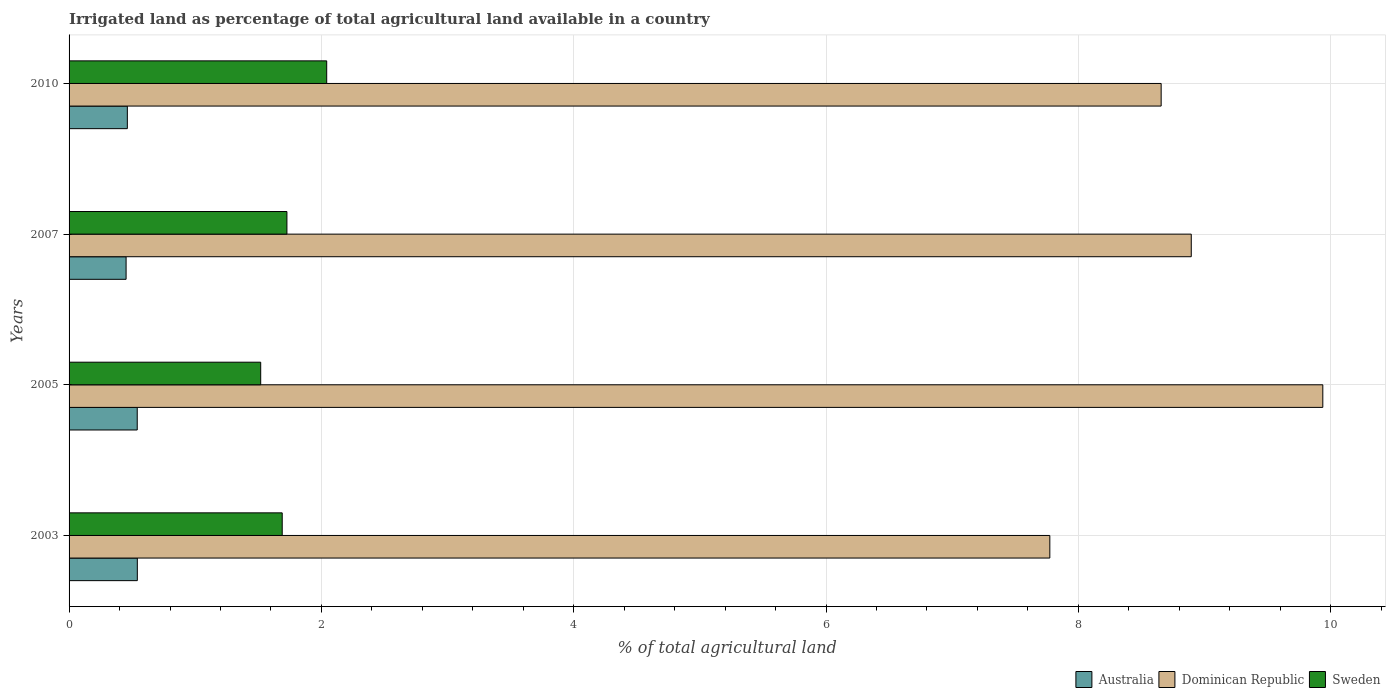Are the number of bars per tick equal to the number of legend labels?
Your answer should be very brief. Yes. Are the number of bars on each tick of the Y-axis equal?
Keep it short and to the point. Yes. In how many cases, is the number of bars for a given year not equal to the number of legend labels?
Offer a very short reply. 0. What is the percentage of irrigated land in Sweden in 2005?
Provide a short and direct response. 1.52. Across all years, what is the maximum percentage of irrigated land in Sweden?
Make the answer very short. 2.04. Across all years, what is the minimum percentage of irrigated land in Sweden?
Your answer should be very brief. 1.52. In which year was the percentage of irrigated land in Australia maximum?
Give a very brief answer. 2003. What is the total percentage of irrigated land in Dominican Republic in the graph?
Your response must be concise. 35.26. What is the difference between the percentage of irrigated land in Australia in 2005 and that in 2007?
Provide a succinct answer. 0.09. What is the difference between the percentage of irrigated land in Australia in 2010 and the percentage of irrigated land in Sweden in 2003?
Provide a short and direct response. -1.23. What is the average percentage of irrigated land in Sweden per year?
Your answer should be very brief. 1.74. In the year 2007, what is the difference between the percentage of irrigated land in Australia and percentage of irrigated land in Sweden?
Offer a very short reply. -1.27. In how many years, is the percentage of irrigated land in Sweden greater than 6.4 %?
Provide a succinct answer. 0. What is the ratio of the percentage of irrigated land in Australia in 2003 to that in 2005?
Provide a succinct answer. 1. Is the difference between the percentage of irrigated land in Australia in 2003 and 2007 greater than the difference between the percentage of irrigated land in Sweden in 2003 and 2007?
Ensure brevity in your answer.  Yes. What is the difference between the highest and the second highest percentage of irrigated land in Sweden?
Your answer should be compact. 0.32. What is the difference between the highest and the lowest percentage of irrigated land in Dominican Republic?
Make the answer very short. 2.16. What does the 2nd bar from the top in 2003 represents?
Keep it short and to the point. Dominican Republic. What does the 3rd bar from the bottom in 2010 represents?
Provide a short and direct response. Sweden. Is it the case that in every year, the sum of the percentage of irrigated land in Sweden and percentage of irrigated land in Australia is greater than the percentage of irrigated land in Dominican Republic?
Keep it short and to the point. No. How many bars are there?
Make the answer very short. 12. Are all the bars in the graph horizontal?
Offer a terse response. Yes. What is the difference between two consecutive major ticks on the X-axis?
Give a very brief answer. 2. Does the graph contain grids?
Ensure brevity in your answer.  Yes. How many legend labels are there?
Provide a succinct answer. 3. What is the title of the graph?
Provide a succinct answer. Irrigated land as percentage of total agricultural land available in a country. Does "Burkina Faso" appear as one of the legend labels in the graph?
Your answer should be very brief. No. What is the label or title of the X-axis?
Offer a very short reply. % of total agricultural land. What is the % of total agricultural land of Australia in 2003?
Offer a terse response. 0.54. What is the % of total agricultural land in Dominican Republic in 2003?
Keep it short and to the point. 7.77. What is the % of total agricultural land of Sweden in 2003?
Your response must be concise. 1.69. What is the % of total agricultural land in Australia in 2005?
Your answer should be very brief. 0.54. What is the % of total agricultural land in Dominican Republic in 2005?
Your response must be concise. 9.94. What is the % of total agricultural land in Sweden in 2005?
Give a very brief answer. 1.52. What is the % of total agricultural land in Australia in 2007?
Provide a succinct answer. 0.45. What is the % of total agricultural land in Dominican Republic in 2007?
Your answer should be compact. 8.9. What is the % of total agricultural land in Sweden in 2007?
Your response must be concise. 1.73. What is the % of total agricultural land of Australia in 2010?
Offer a terse response. 0.46. What is the % of total agricultural land of Dominican Republic in 2010?
Your response must be concise. 8.66. What is the % of total agricultural land of Sweden in 2010?
Your answer should be very brief. 2.04. Across all years, what is the maximum % of total agricultural land of Australia?
Make the answer very short. 0.54. Across all years, what is the maximum % of total agricultural land of Dominican Republic?
Offer a very short reply. 9.94. Across all years, what is the maximum % of total agricultural land in Sweden?
Ensure brevity in your answer.  2.04. Across all years, what is the minimum % of total agricultural land in Australia?
Give a very brief answer. 0.45. Across all years, what is the minimum % of total agricultural land in Dominican Republic?
Provide a short and direct response. 7.77. Across all years, what is the minimum % of total agricultural land of Sweden?
Provide a short and direct response. 1.52. What is the total % of total agricultural land in Australia in the graph?
Your answer should be compact. 2. What is the total % of total agricultural land in Dominican Republic in the graph?
Your answer should be very brief. 35.26. What is the total % of total agricultural land in Sweden in the graph?
Give a very brief answer. 6.98. What is the difference between the % of total agricultural land of Australia in 2003 and that in 2005?
Ensure brevity in your answer.  0. What is the difference between the % of total agricultural land in Dominican Republic in 2003 and that in 2005?
Your answer should be compact. -2.16. What is the difference between the % of total agricultural land in Sweden in 2003 and that in 2005?
Provide a short and direct response. 0.17. What is the difference between the % of total agricultural land in Australia in 2003 and that in 2007?
Your answer should be compact. 0.09. What is the difference between the % of total agricultural land of Dominican Republic in 2003 and that in 2007?
Your response must be concise. -1.12. What is the difference between the % of total agricultural land of Sweden in 2003 and that in 2007?
Ensure brevity in your answer.  -0.04. What is the difference between the % of total agricultural land in Australia in 2003 and that in 2010?
Offer a terse response. 0.08. What is the difference between the % of total agricultural land of Dominican Republic in 2003 and that in 2010?
Your answer should be very brief. -0.88. What is the difference between the % of total agricultural land of Sweden in 2003 and that in 2010?
Offer a very short reply. -0.35. What is the difference between the % of total agricultural land in Australia in 2005 and that in 2007?
Your answer should be compact. 0.09. What is the difference between the % of total agricultural land in Dominican Republic in 2005 and that in 2007?
Offer a very short reply. 1.04. What is the difference between the % of total agricultural land of Sweden in 2005 and that in 2007?
Keep it short and to the point. -0.21. What is the difference between the % of total agricultural land in Australia in 2005 and that in 2010?
Give a very brief answer. 0.08. What is the difference between the % of total agricultural land in Dominican Republic in 2005 and that in 2010?
Your answer should be compact. 1.28. What is the difference between the % of total agricultural land of Sweden in 2005 and that in 2010?
Offer a terse response. -0.52. What is the difference between the % of total agricultural land of Australia in 2007 and that in 2010?
Your answer should be compact. -0.01. What is the difference between the % of total agricultural land of Dominican Republic in 2007 and that in 2010?
Give a very brief answer. 0.24. What is the difference between the % of total agricultural land of Sweden in 2007 and that in 2010?
Provide a succinct answer. -0.32. What is the difference between the % of total agricultural land in Australia in 2003 and the % of total agricultural land in Dominican Republic in 2005?
Offer a very short reply. -9.4. What is the difference between the % of total agricultural land of Australia in 2003 and the % of total agricultural land of Sweden in 2005?
Offer a very short reply. -0.98. What is the difference between the % of total agricultural land in Dominican Republic in 2003 and the % of total agricultural land in Sweden in 2005?
Give a very brief answer. 6.26. What is the difference between the % of total agricultural land in Australia in 2003 and the % of total agricultural land in Dominican Republic in 2007?
Your answer should be very brief. -8.35. What is the difference between the % of total agricultural land in Australia in 2003 and the % of total agricultural land in Sweden in 2007?
Provide a short and direct response. -1.19. What is the difference between the % of total agricultural land in Dominican Republic in 2003 and the % of total agricultural land in Sweden in 2007?
Make the answer very short. 6.05. What is the difference between the % of total agricultural land of Australia in 2003 and the % of total agricultural land of Dominican Republic in 2010?
Offer a terse response. -8.12. What is the difference between the % of total agricultural land in Australia in 2003 and the % of total agricultural land in Sweden in 2010?
Provide a short and direct response. -1.5. What is the difference between the % of total agricultural land in Dominican Republic in 2003 and the % of total agricultural land in Sweden in 2010?
Offer a terse response. 5.73. What is the difference between the % of total agricultural land of Australia in 2005 and the % of total agricultural land of Dominican Republic in 2007?
Offer a very short reply. -8.36. What is the difference between the % of total agricultural land of Australia in 2005 and the % of total agricultural land of Sweden in 2007?
Your answer should be very brief. -1.19. What is the difference between the % of total agricultural land of Dominican Republic in 2005 and the % of total agricultural land of Sweden in 2007?
Ensure brevity in your answer.  8.21. What is the difference between the % of total agricultural land in Australia in 2005 and the % of total agricultural land in Dominican Republic in 2010?
Offer a terse response. -8.12. What is the difference between the % of total agricultural land in Australia in 2005 and the % of total agricultural land in Sweden in 2010?
Give a very brief answer. -1.5. What is the difference between the % of total agricultural land in Dominican Republic in 2005 and the % of total agricultural land in Sweden in 2010?
Provide a short and direct response. 7.9. What is the difference between the % of total agricultural land of Australia in 2007 and the % of total agricultural land of Dominican Republic in 2010?
Offer a terse response. -8.2. What is the difference between the % of total agricultural land in Australia in 2007 and the % of total agricultural land in Sweden in 2010?
Offer a very short reply. -1.59. What is the difference between the % of total agricultural land of Dominican Republic in 2007 and the % of total agricultural land of Sweden in 2010?
Your answer should be very brief. 6.85. What is the average % of total agricultural land of Australia per year?
Your answer should be compact. 0.5. What is the average % of total agricultural land in Dominican Republic per year?
Offer a very short reply. 8.82. What is the average % of total agricultural land of Sweden per year?
Your answer should be very brief. 1.74. In the year 2003, what is the difference between the % of total agricultural land in Australia and % of total agricultural land in Dominican Republic?
Keep it short and to the point. -7.23. In the year 2003, what is the difference between the % of total agricultural land in Australia and % of total agricultural land in Sweden?
Ensure brevity in your answer.  -1.15. In the year 2003, what is the difference between the % of total agricultural land of Dominican Republic and % of total agricultural land of Sweden?
Your answer should be very brief. 6.08. In the year 2005, what is the difference between the % of total agricultural land of Australia and % of total agricultural land of Dominican Republic?
Your answer should be compact. -9.4. In the year 2005, what is the difference between the % of total agricultural land of Australia and % of total agricultural land of Sweden?
Your answer should be very brief. -0.98. In the year 2005, what is the difference between the % of total agricultural land in Dominican Republic and % of total agricultural land in Sweden?
Your answer should be compact. 8.42. In the year 2007, what is the difference between the % of total agricultural land in Australia and % of total agricultural land in Dominican Republic?
Offer a very short reply. -8.44. In the year 2007, what is the difference between the % of total agricultural land of Australia and % of total agricultural land of Sweden?
Offer a terse response. -1.27. In the year 2007, what is the difference between the % of total agricultural land in Dominican Republic and % of total agricultural land in Sweden?
Ensure brevity in your answer.  7.17. In the year 2010, what is the difference between the % of total agricultural land of Australia and % of total agricultural land of Dominican Republic?
Provide a short and direct response. -8.19. In the year 2010, what is the difference between the % of total agricultural land of Australia and % of total agricultural land of Sweden?
Your answer should be compact. -1.58. In the year 2010, what is the difference between the % of total agricultural land in Dominican Republic and % of total agricultural land in Sweden?
Provide a succinct answer. 6.61. What is the ratio of the % of total agricultural land of Dominican Republic in 2003 to that in 2005?
Your answer should be very brief. 0.78. What is the ratio of the % of total agricultural land in Sweden in 2003 to that in 2005?
Your response must be concise. 1.11. What is the ratio of the % of total agricultural land of Australia in 2003 to that in 2007?
Your response must be concise. 1.2. What is the ratio of the % of total agricultural land in Dominican Republic in 2003 to that in 2007?
Give a very brief answer. 0.87. What is the ratio of the % of total agricultural land in Sweden in 2003 to that in 2007?
Give a very brief answer. 0.98. What is the ratio of the % of total agricultural land in Australia in 2003 to that in 2010?
Ensure brevity in your answer.  1.17. What is the ratio of the % of total agricultural land in Dominican Republic in 2003 to that in 2010?
Offer a terse response. 0.9. What is the ratio of the % of total agricultural land in Sweden in 2003 to that in 2010?
Keep it short and to the point. 0.83. What is the ratio of the % of total agricultural land of Australia in 2005 to that in 2007?
Make the answer very short. 1.2. What is the ratio of the % of total agricultural land in Dominican Republic in 2005 to that in 2007?
Your answer should be compact. 1.12. What is the ratio of the % of total agricultural land of Sweden in 2005 to that in 2007?
Make the answer very short. 0.88. What is the ratio of the % of total agricultural land in Australia in 2005 to that in 2010?
Offer a very short reply. 1.17. What is the ratio of the % of total agricultural land in Dominican Republic in 2005 to that in 2010?
Provide a short and direct response. 1.15. What is the ratio of the % of total agricultural land of Sweden in 2005 to that in 2010?
Give a very brief answer. 0.74. What is the ratio of the % of total agricultural land in Australia in 2007 to that in 2010?
Provide a short and direct response. 0.98. What is the ratio of the % of total agricultural land in Dominican Republic in 2007 to that in 2010?
Your response must be concise. 1.03. What is the ratio of the % of total agricultural land in Sweden in 2007 to that in 2010?
Keep it short and to the point. 0.85. What is the difference between the highest and the second highest % of total agricultural land of Australia?
Offer a very short reply. 0. What is the difference between the highest and the second highest % of total agricultural land of Dominican Republic?
Offer a terse response. 1.04. What is the difference between the highest and the second highest % of total agricultural land in Sweden?
Keep it short and to the point. 0.32. What is the difference between the highest and the lowest % of total agricultural land in Australia?
Keep it short and to the point. 0.09. What is the difference between the highest and the lowest % of total agricultural land in Dominican Republic?
Offer a terse response. 2.16. What is the difference between the highest and the lowest % of total agricultural land in Sweden?
Offer a terse response. 0.52. 